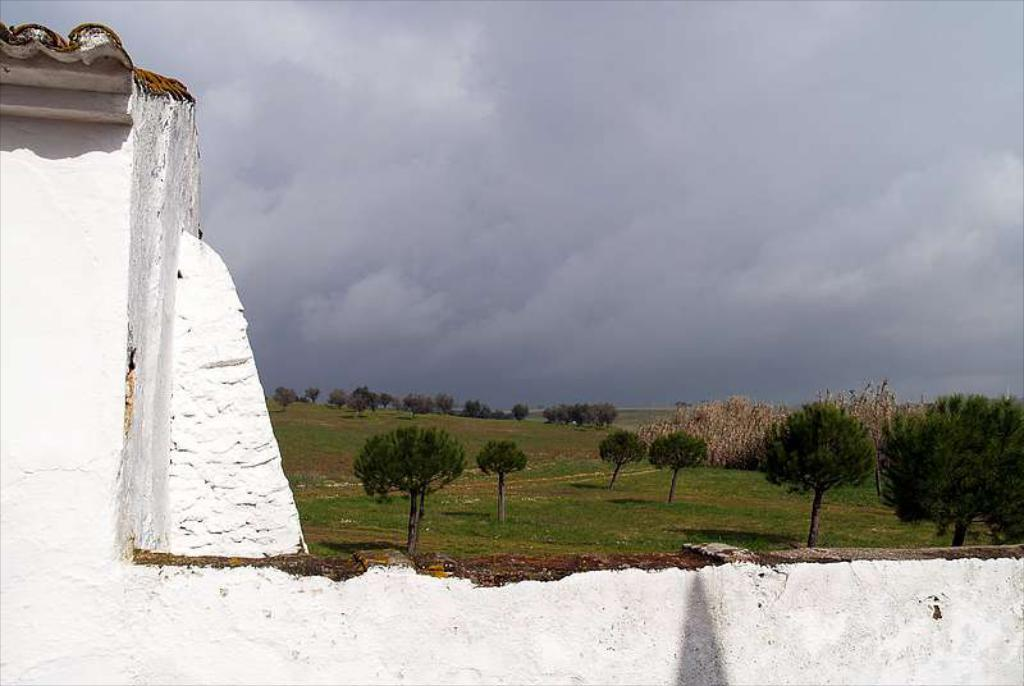What type of vegetation can be seen in the image? There are trees in the image. What part of the natural environment is visible in the image? The sky is visible in the image. What type of structure is present at the bottom of the image? There is a wall at the bottom of the image. How many apples are hanging from the trees in the image? There is no mention of apples in the image, so we cannot determine the number of apples present. What type of pollution can be seen in the image? There is no mention of pollution in the image, so we cannot determine the presence or type of pollution. 